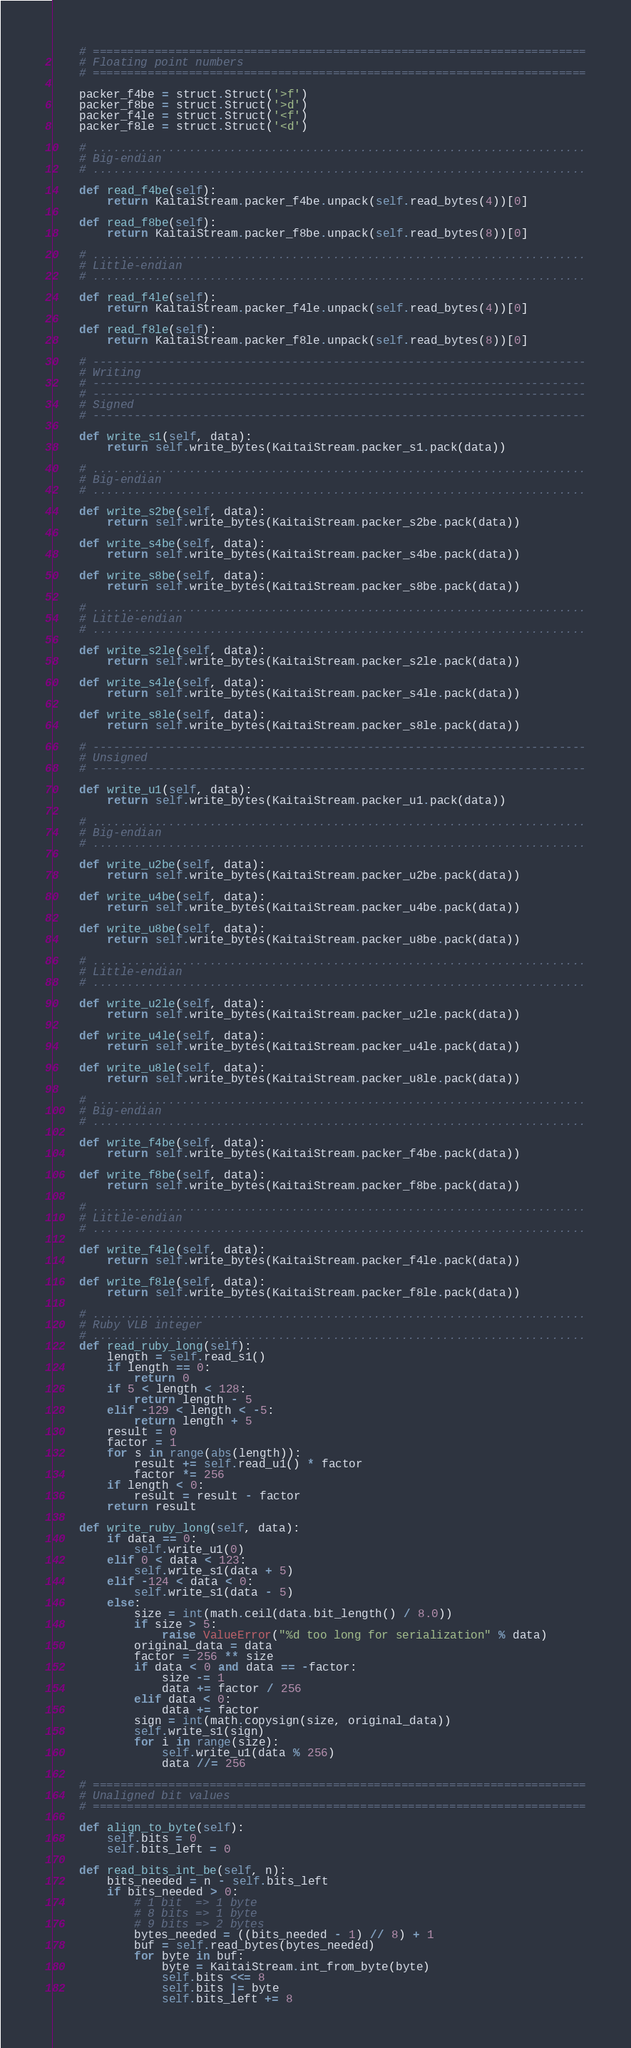Convert code to text. <code><loc_0><loc_0><loc_500><loc_500><_Python_>    # ========================================================================
    # Floating point numbers
    # ========================================================================

    packer_f4be = struct.Struct('>f')
    packer_f8be = struct.Struct('>d')
    packer_f4le = struct.Struct('<f')
    packer_f8le = struct.Struct('<d')

    # ........................................................................
    # Big-endian
    # ........................................................................

    def read_f4be(self):
        return KaitaiStream.packer_f4be.unpack(self.read_bytes(4))[0]

    def read_f8be(self):
        return KaitaiStream.packer_f8be.unpack(self.read_bytes(8))[0]

    # ........................................................................
    # Little-endian
    # ........................................................................

    def read_f4le(self):
        return KaitaiStream.packer_f4le.unpack(self.read_bytes(4))[0]

    def read_f8le(self):
        return KaitaiStream.packer_f8le.unpack(self.read_bytes(8))[0]

    # ------------------------------------------------------------------------
    # Writing
    # ------------------------------------------------------------------------
    # ------------------------------------------------------------------------
    # Signed
    # ------------------------------------------------------------------------

    def write_s1(self, data):
        return self.write_bytes(KaitaiStream.packer_s1.pack(data))

    # ........................................................................
    # Big-endian
    # ........................................................................

    def write_s2be(self, data):
        return self.write_bytes(KaitaiStream.packer_s2be.pack(data))

    def write_s4be(self, data):
        return self.write_bytes(KaitaiStream.packer_s4be.pack(data))

    def write_s8be(self, data):
        return self.write_bytes(KaitaiStream.packer_s8be.pack(data))

    # ........................................................................
    # Little-endian
    # ........................................................................

    def write_s2le(self, data):
        return self.write_bytes(KaitaiStream.packer_s2le.pack(data))

    def write_s4le(self, data):
        return self.write_bytes(KaitaiStream.packer_s4le.pack(data))

    def write_s8le(self, data):
        return self.write_bytes(KaitaiStream.packer_s8le.pack(data))

    # ------------------------------------------------------------------------
    # Unsigned
    # ------------------------------------------------------------------------

    def write_u1(self, data):
        return self.write_bytes(KaitaiStream.packer_u1.pack(data))

    # ........................................................................
    # Big-endian
    # ........................................................................

    def write_u2be(self, data):
        return self.write_bytes(KaitaiStream.packer_u2be.pack(data))

    def write_u4be(self, data):
        return self.write_bytes(KaitaiStream.packer_u4be.pack(data))

    def write_u8be(self, data):
        return self.write_bytes(KaitaiStream.packer_u8be.pack(data))

    # ........................................................................
    # Little-endian
    # ........................................................................

    def write_u2le(self, data):
        return self.write_bytes(KaitaiStream.packer_u2le.pack(data))

    def write_u4le(self, data):
        return self.write_bytes(KaitaiStream.packer_u4le.pack(data))

    def write_u8le(self, data):
        return self.write_bytes(KaitaiStream.packer_u8le.pack(data))

    # ........................................................................
    # Big-endian
    # ........................................................................

    def write_f4be(self, data):
        return self.write_bytes(KaitaiStream.packer_f4be.pack(data))

    def write_f8be(self, data):
        return self.write_bytes(KaitaiStream.packer_f8be.pack(data))

    # ........................................................................
    # Little-endian
    # ........................................................................

    def write_f4le(self, data):
        return self.write_bytes(KaitaiStream.packer_f4le.pack(data))

    def write_f8le(self, data):
        return self.write_bytes(KaitaiStream.packer_f8le.pack(data))

    # ........................................................................
    # Ruby VLB integer
    # ........................................................................
    def read_ruby_long(self):
        length = self.read_s1()
        if length == 0:
            return 0
        if 5 < length < 128:
            return length - 5
        elif -129 < length < -5:
            return length + 5
        result = 0
        factor = 1
        for s in range(abs(length)):
            result += self.read_u1() * factor
            factor *= 256
        if length < 0:
            result = result - factor
        return result

    def write_ruby_long(self, data):
        if data == 0:
            self.write_u1(0)
        elif 0 < data < 123:
            self.write_s1(data + 5)
        elif -124 < data < 0:
            self.write_s1(data - 5)
        else:
            size = int(math.ceil(data.bit_length() / 8.0))
            if size > 5:
                raise ValueError("%d too long for serialization" % data)
            original_data = data
            factor = 256 ** size
            if data < 0 and data == -factor:
                size -= 1
                data += factor / 256
            elif data < 0:
                data += factor
            sign = int(math.copysign(size, original_data))
            self.write_s1(sign)
            for i in range(size):
                self.write_u1(data % 256)
                data //= 256

    # ========================================================================
    # Unaligned bit values
    # ========================================================================

    def align_to_byte(self):
        self.bits = 0
        self.bits_left = 0

    def read_bits_int_be(self, n):
        bits_needed = n - self.bits_left
        if bits_needed > 0:
            # 1 bit  => 1 byte
            # 8 bits => 1 byte
            # 9 bits => 2 bytes
            bytes_needed = ((bits_needed - 1) // 8) + 1
            buf = self.read_bytes(bytes_needed)
            for byte in buf:
                byte = KaitaiStream.int_from_byte(byte)
                self.bits <<= 8
                self.bits |= byte
                self.bits_left += 8
</code> 